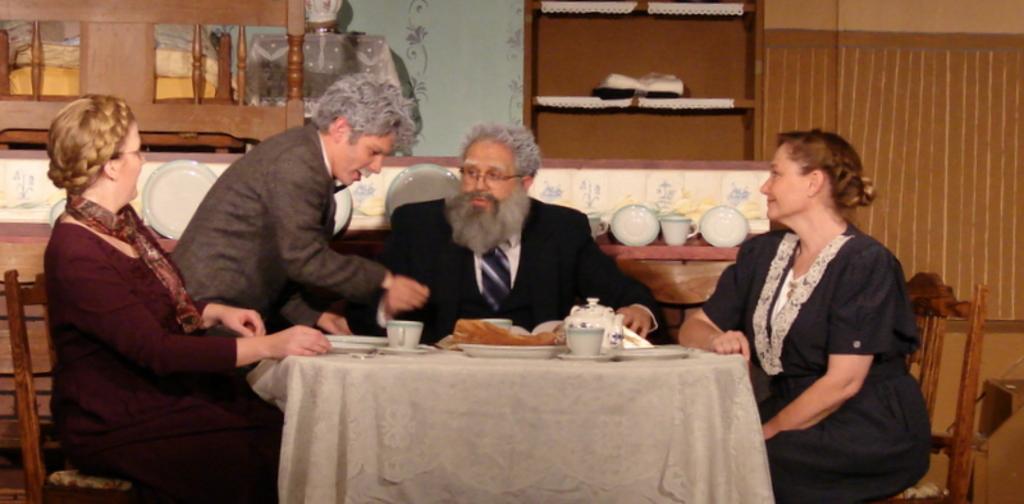How would you summarize this image in a sentence or two? In this image we can see a group of persons are sitting on the chair, and in front here is the table and cup and plates and some objects on it,and here a person is standing, and at back here is the wall. 